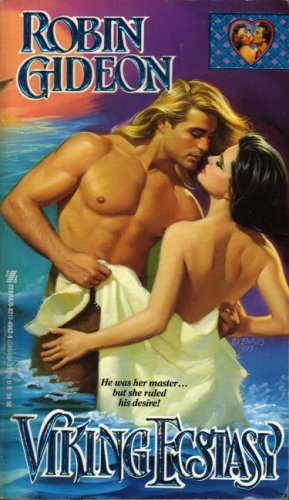Who wrote this book?
Answer the question using a single word or phrase. Robin Gideon What is the title of this book? Viking Ecstasy (Zebra books) What type of book is this? Romance Is this a romantic book? Yes Is this a sci-fi book? No 